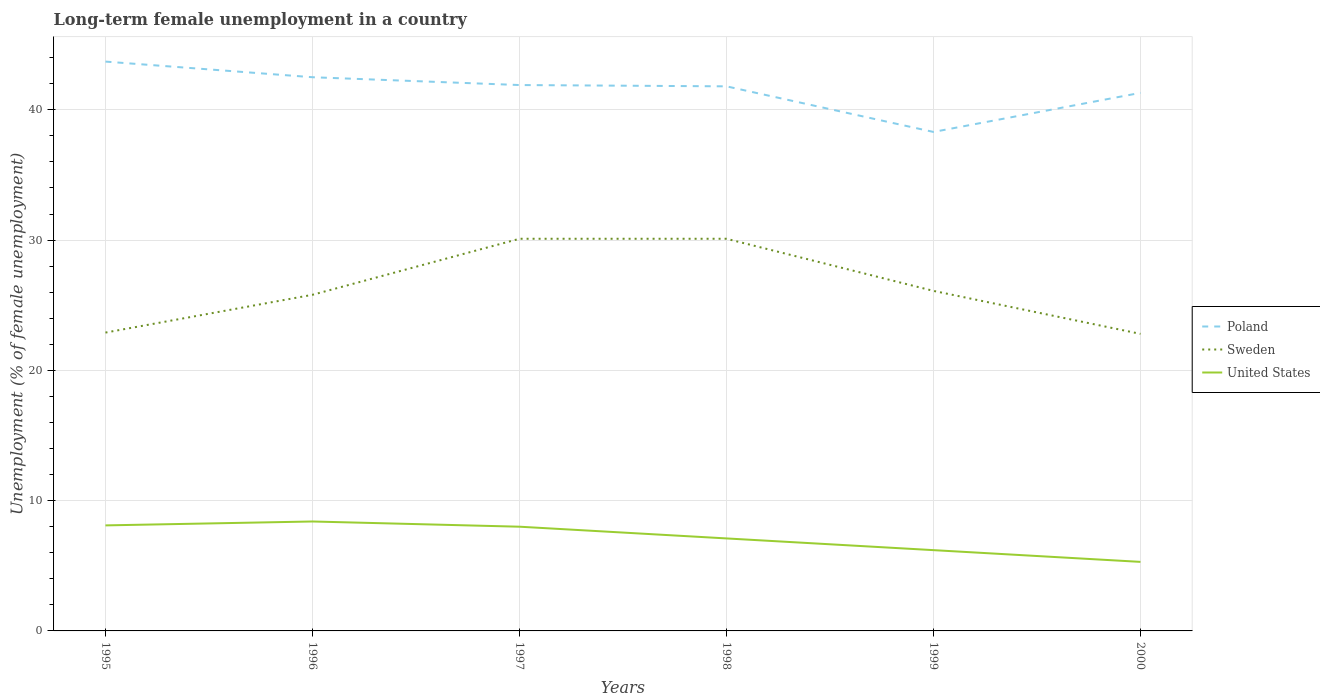How many different coloured lines are there?
Ensure brevity in your answer.  3. Across all years, what is the maximum percentage of long-term unemployed female population in Poland?
Your response must be concise. 38.3. What is the total percentage of long-term unemployed female population in Poland in the graph?
Offer a very short reply. 1.9. What is the difference between the highest and the second highest percentage of long-term unemployed female population in United States?
Keep it short and to the point. 3.1. What is the difference between the highest and the lowest percentage of long-term unemployed female population in United States?
Provide a short and direct response. 3. How many years are there in the graph?
Offer a very short reply. 6. What is the difference between two consecutive major ticks on the Y-axis?
Provide a succinct answer. 10. Are the values on the major ticks of Y-axis written in scientific E-notation?
Provide a short and direct response. No. Does the graph contain any zero values?
Your answer should be compact. No. How are the legend labels stacked?
Ensure brevity in your answer.  Vertical. What is the title of the graph?
Provide a succinct answer. Long-term female unemployment in a country. What is the label or title of the X-axis?
Offer a very short reply. Years. What is the label or title of the Y-axis?
Your answer should be very brief. Unemployment (% of female unemployment). What is the Unemployment (% of female unemployment) in Poland in 1995?
Your answer should be very brief. 43.7. What is the Unemployment (% of female unemployment) in Sweden in 1995?
Offer a terse response. 22.9. What is the Unemployment (% of female unemployment) of United States in 1995?
Keep it short and to the point. 8.1. What is the Unemployment (% of female unemployment) of Poland in 1996?
Offer a very short reply. 42.5. What is the Unemployment (% of female unemployment) in Sweden in 1996?
Give a very brief answer. 25.8. What is the Unemployment (% of female unemployment) of United States in 1996?
Provide a succinct answer. 8.4. What is the Unemployment (% of female unemployment) in Poland in 1997?
Your response must be concise. 41.9. What is the Unemployment (% of female unemployment) of Sweden in 1997?
Your answer should be compact. 30.1. What is the Unemployment (% of female unemployment) in Poland in 1998?
Provide a succinct answer. 41.8. What is the Unemployment (% of female unemployment) in Sweden in 1998?
Offer a very short reply. 30.1. What is the Unemployment (% of female unemployment) in United States in 1998?
Keep it short and to the point. 7.1. What is the Unemployment (% of female unemployment) of Poland in 1999?
Offer a very short reply. 38.3. What is the Unemployment (% of female unemployment) in Sweden in 1999?
Keep it short and to the point. 26.1. What is the Unemployment (% of female unemployment) of United States in 1999?
Your answer should be compact. 6.2. What is the Unemployment (% of female unemployment) in Poland in 2000?
Ensure brevity in your answer.  41.3. What is the Unemployment (% of female unemployment) in Sweden in 2000?
Your answer should be very brief. 22.8. What is the Unemployment (% of female unemployment) in United States in 2000?
Your response must be concise. 5.3. Across all years, what is the maximum Unemployment (% of female unemployment) in Poland?
Your response must be concise. 43.7. Across all years, what is the maximum Unemployment (% of female unemployment) of Sweden?
Ensure brevity in your answer.  30.1. Across all years, what is the maximum Unemployment (% of female unemployment) in United States?
Provide a short and direct response. 8.4. Across all years, what is the minimum Unemployment (% of female unemployment) in Poland?
Provide a succinct answer. 38.3. Across all years, what is the minimum Unemployment (% of female unemployment) of Sweden?
Offer a very short reply. 22.8. Across all years, what is the minimum Unemployment (% of female unemployment) in United States?
Make the answer very short. 5.3. What is the total Unemployment (% of female unemployment) of Poland in the graph?
Offer a very short reply. 249.5. What is the total Unemployment (% of female unemployment) in Sweden in the graph?
Your response must be concise. 157.8. What is the total Unemployment (% of female unemployment) of United States in the graph?
Provide a succinct answer. 43.1. What is the difference between the Unemployment (% of female unemployment) of Poland in 1995 and that in 1996?
Offer a terse response. 1.2. What is the difference between the Unemployment (% of female unemployment) in Sweden in 1995 and that in 1997?
Keep it short and to the point. -7.2. What is the difference between the Unemployment (% of female unemployment) of Poland in 1995 and that in 1998?
Offer a terse response. 1.9. What is the difference between the Unemployment (% of female unemployment) of United States in 1995 and that in 1998?
Your answer should be compact. 1. What is the difference between the Unemployment (% of female unemployment) of Poland in 1995 and that in 2000?
Provide a succinct answer. 2.4. What is the difference between the Unemployment (% of female unemployment) in Sweden in 1995 and that in 2000?
Offer a very short reply. 0.1. What is the difference between the Unemployment (% of female unemployment) in Poland in 1996 and that in 1997?
Offer a terse response. 0.6. What is the difference between the Unemployment (% of female unemployment) of United States in 1996 and that in 1997?
Ensure brevity in your answer.  0.4. What is the difference between the Unemployment (% of female unemployment) in Sweden in 1996 and that in 1998?
Give a very brief answer. -4.3. What is the difference between the Unemployment (% of female unemployment) in Sweden in 1996 and that in 2000?
Offer a terse response. 3. What is the difference between the Unemployment (% of female unemployment) of United States in 1996 and that in 2000?
Give a very brief answer. 3.1. What is the difference between the Unemployment (% of female unemployment) of Poland in 1997 and that in 1998?
Your answer should be compact. 0.1. What is the difference between the Unemployment (% of female unemployment) of Poland in 1997 and that in 1999?
Your answer should be compact. 3.6. What is the difference between the Unemployment (% of female unemployment) in Sweden in 1997 and that in 1999?
Provide a short and direct response. 4. What is the difference between the Unemployment (% of female unemployment) of United States in 1997 and that in 1999?
Give a very brief answer. 1.8. What is the difference between the Unemployment (% of female unemployment) in Poland in 1997 and that in 2000?
Offer a very short reply. 0.6. What is the difference between the Unemployment (% of female unemployment) in Sweden in 1997 and that in 2000?
Provide a succinct answer. 7.3. What is the difference between the Unemployment (% of female unemployment) of Sweden in 1998 and that in 1999?
Your answer should be very brief. 4. What is the difference between the Unemployment (% of female unemployment) in Poland in 1998 and that in 2000?
Your response must be concise. 0.5. What is the difference between the Unemployment (% of female unemployment) in Sweden in 1998 and that in 2000?
Your answer should be very brief. 7.3. What is the difference between the Unemployment (% of female unemployment) in United States in 1998 and that in 2000?
Your answer should be compact. 1.8. What is the difference between the Unemployment (% of female unemployment) of Sweden in 1999 and that in 2000?
Provide a succinct answer. 3.3. What is the difference between the Unemployment (% of female unemployment) of United States in 1999 and that in 2000?
Provide a succinct answer. 0.9. What is the difference between the Unemployment (% of female unemployment) in Poland in 1995 and the Unemployment (% of female unemployment) in Sweden in 1996?
Your answer should be very brief. 17.9. What is the difference between the Unemployment (% of female unemployment) in Poland in 1995 and the Unemployment (% of female unemployment) in United States in 1996?
Your answer should be very brief. 35.3. What is the difference between the Unemployment (% of female unemployment) in Sweden in 1995 and the Unemployment (% of female unemployment) in United States in 1996?
Your answer should be compact. 14.5. What is the difference between the Unemployment (% of female unemployment) of Poland in 1995 and the Unemployment (% of female unemployment) of United States in 1997?
Provide a succinct answer. 35.7. What is the difference between the Unemployment (% of female unemployment) of Poland in 1995 and the Unemployment (% of female unemployment) of United States in 1998?
Provide a succinct answer. 36.6. What is the difference between the Unemployment (% of female unemployment) in Poland in 1995 and the Unemployment (% of female unemployment) in Sweden in 1999?
Your response must be concise. 17.6. What is the difference between the Unemployment (% of female unemployment) of Poland in 1995 and the Unemployment (% of female unemployment) of United States in 1999?
Your answer should be very brief. 37.5. What is the difference between the Unemployment (% of female unemployment) in Poland in 1995 and the Unemployment (% of female unemployment) in Sweden in 2000?
Give a very brief answer. 20.9. What is the difference between the Unemployment (% of female unemployment) of Poland in 1995 and the Unemployment (% of female unemployment) of United States in 2000?
Make the answer very short. 38.4. What is the difference between the Unemployment (% of female unemployment) of Sweden in 1995 and the Unemployment (% of female unemployment) of United States in 2000?
Provide a succinct answer. 17.6. What is the difference between the Unemployment (% of female unemployment) of Poland in 1996 and the Unemployment (% of female unemployment) of United States in 1997?
Offer a terse response. 34.5. What is the difference between the Unemployment (% of female unemployment) of Poland in 1996 and the Unemployment (% of female unemployment) of United States in 1998?
Provide a short and direct response. 35.4. What is the difference between the Unemployment (% of female unemployment) in Poland in 1996 and the Unemployment (% of female unemployment) in United States in 1999?
Ensure brevity in your answer.  36.3. What is the difference between the Unemployment (% of female unemployment) in Sweden in 1996 and the Unemployment (% of female unemployment) in United States in 1999?
Your answer should be compact. 19.6. What is the difference between the Unemployment (% of female unemployment) of Poland in 1996 and the Unemployment (% of female unemployment) of United States in 2000?
Your answer should be compact. 37.2. What is the difference between the Unemployment (% of female unemployment) in Sweden in 1996 and the Unemployment (% of female unemployment) in United States in 2000?
Make the answer very short. 20.5. What is the difference between the Unemployment (% of female unemployment) of Poland in 1997 and the Unemployment (% of female unemployment) of Sweden in 1998?
Make the answer very short. 11.8. What is the difference between the Unemployment (% of female unemployment) in Poland in 1997 and the Unemployment (% of female unemployment) in United States in 1998?
Your response must be concise. 34.8. What is the difference between the Unemployment (% of female unemployment) in Sweden in 1997 and the Unemployment (% of female unemployment) in United States in 1998?
Provide a succinct answer. 23. What is the difference between the Unemployment (% of female unemployment) of Poland in 1997 and the Unemployment (% of female unemployment) of Sweden in 1999?
Offer a very short reply. 15.8. What is the difference between the Unemployment (% of female unemployment) of Poland in 1997 and the Unemployment (% of female unemployment) of United States in 1999?
Offer a very short reply. 35.7. What is the difference between the Unemployment (% of female unemployment) in Sweden in 1997 and the Unemployment (% of female unemployment) in United States in 1999?
Your answer should be very brief. 23.9. What is the difference between the Unemployment (% of female unemployment) in Poland in 1997 and the Unemployment (% of female unemployment) in United States in 2000?
Offer a terse response. 36.6. What is the difference between the Unemployment (% of female unemployment) of Sweden in 1997 and the Unemployment (% of female unemployment) of United States in 2000?
Make the answer very short. 24.8. What is the difference between the Unemployment (% of female unemployment) in Poland in 1998 and the Unemployment (% of female unemployment) in Sweden in 1999?
Offer a very short reply. 15.7. What is the difference between the Unemployment (% of female unemployment) of Poland in 1998 and the Unemployment (% of female unemployment) of United States in 1999?
Give a very brief answer. 35.6. What is the difference between the Unemployment (% of female unemployment) of Sweden in 1998 and the Unemployment (% of female unemployment) of United States in 1999?
Your response must be concise. 23.9. What is the difference between the Unemployment (% of female unemployment) of Poland in 1998 and the Unemployment (% of female unemployment) of Sweden in 2000?
Give a very brief answer. 19. What is the difference between the Unemployment (% of female unemployment) of Poland in 1998 and the Unemployment (% of female unemployment) of United States in 2000?
Offer a terse response. 36.5. What is the difference between the Unemployment (% of female unemployment) of Sweden in 1998 and the Unemployment (% of female unemployment) of United States in 2000?
Give a very brief answer. 24.8. What is the difference between the Unemployment (% of female unemployment) of Sweden in 1999 and the Unemployment (% of female unemployment) of United States in 2000?
Give a very brief answer. 20.8. What is the average Unemployment (% of female unemployment) of Poland per year?
Keep it short and to the point. 41.58. What is the average Unemployment (% of female unemployment) in Sweden per year?
Provide a short and direct response. 26.3. What is the average Unemployment (% of female unemployment) of United States per year?
Offer a terse response. 7.18. In the year 1995, what is the difference between the Unemployment (% of female unemployment) of Poland and Unemployment (% of female unemployment) of Sweden?
Your answer should be very brief. 20.8. In the year 1995, what is the difference between the Unemployment (% of female unemployment) of Poland and Unemployment (% of female unemployment) of United States?
Your answer should be very brief. 35.6. In the year 1995, what is the difference between the Unemployment (% of female unemployment) in Sweden and Unemployment (% of female unemployment) in United States?
Make the answer very short. 14.8. In the year 1996, what is the difference between the Unemployment (% of female unemployment) of Poland and Unemployment (% of female unemployment) of Sweden?
Offer a terse response. 16.7. In the year 1996, what is the difference between the Unemployment (% of female unemployment) in Poland and Unemployment (% of female unemployment) in United States?
Make the answer very short. 34.1. In the year 1996, what is the difference between the Unemployment (% of female unemployment) of Sweden and Unemployment (% of female unemployment) of United States?
Your answer should be compact. 17.4. In the year 1997, what is the difference between the Unemployment (% of female unemployment) in Poland and Unemployment (% of female unemployment) in Sweden?
Your answer should be very brief. 11.8. In the year 1997, what is the difference between the Unemployment (% of female unemployment) of Poland and Unemployment (% of female unemployment) of United States?
Make the answer very short. 33.9. In the year 1997, what is the difference between the Unemployment (% of female unemployment) of Sweden and Unemployment (% of female unemployment) of United States?
Provide a short and direct response. 22.1. In the year 1998, what is the difference between the Unemployment (% of female unemployment) in Poland and Unemployment (% of female unemployment) in Sweden?
Your response must be concise. 11.7. In the year 1998, what is the difference between the Unemployment (% of female unemployment) in Poland and Unemployment (% of female unemployment) in United States?
Provide a short and direct response. 34.7. In the year 1998, what is the difference between the Unemployment (% of female unemployment) of Sweden and Unemployment (% of female unemployment) of United States?
Make the answer very short. 23. In the year 1999, what is the difference between the Unemployment (% of female unemployment) of Poland and Unemployment (% of female unemployment) of United States?
Keep it short and to the point. 32.1. In the year 1999, what is the difference between the Unemployment (% of female unemployment) in Sweden and Unemployment (% of female unemployment) in United States?
Your response must be concise. 19.9. In the year 2000, what is the difference between the Unemployment (% of female unemployment) in Poland and Unemployment (% of female unemployment) in Sweden?
Keep it short and to the point. 18.5. In the year 2000, what is the difference between the Unemployment (% of female unemployment) in Poland and Unemployment (% of female unemployment) in United States?
Make the answer very short. 36. What is the ratio of the Unemployment (% of female unemployment) of Poland in 1995 to that in 1996?
Make the answer very short. 1.03. What is the ratio of the Unemployment (% of female unemployment) in Sweden in 1995 to that in 1996?
Ensure brevity in your answer.  0.89. What is the ratio of the Unemployment (% of female unemployment) in United States in 1995 to that in 1996?
Provide a short and direct response. 0.96. What is the ratio of the Unemployment (% of female unemployment) in Poland in 1995 to that in 1997?
Make the answer very short. 1.04. What is the ratio of the Unemployment (% of female unemployment) in Sweden in 1995 to that in 1997?
Give a very brief answer. 0.76. What is the ratio of the Unemployment (% of female unemployment) in United States in 1995 to that in 1997?
Offer a very short reply. 1.01. What is the ratio of the Unemployment (% of female unemployment) of Poland in 1995 to that in 1998?
Your answer should be very brief. 1.05. What is the ratio of the Unemployment (% of female unemployment) of Sweden in 1995 to that in 1998?
Make the answer very short. 0.76. What is the ratio of the Unemployment (% of female unemployment) in United States in 1995 to that in 1998?
Your answer should be compact. 1.14. What is the ratio of the Unemployment (% of female unemployment) in Poland in 1995 to that in 1999?
Offer a terse response. 1.14. What is the ratio of the Unemployment (% of female unemployment) of Sweden in 1995 to that in 1999?
Provide a succinct answer. 0.88. What is the ratio of the Unemployment (% of female unemployment) in United States in 1995 to that in 1999?
Your answer should be compact. 1.31. What is the ratio of the Unemployment (% of female unemployment) of Poland in 1995 to that in 2000?
Keep it short and to the point. 1.06. What is the ratio of the Unemployment (% of female unemployment) of United States in 1995 to that in 2000?
Offer a very short reply. 1.53. What is the ratio of the Unemployment (% of female unemployment) in Poland in 1996 to that in 1997?
Make the answer very short. 1.01. What is the ratio of the Unemployment (% of female unemployment) of Poland in 1996 to that in 1998?
Your answer should be compact. 1.02. What is the ratio of the Unemployment (% of female unemployment) of United States in 1996 to that in 1998?
Provide a short and direct response. 1.18. What is the ratio of the Unemployment (% of female unemployment) in Poland in 1996 to that in 1999?
Your answer should be compact. 1.11. What is the ratio of the Unemployment (% of female unemployment) of United States in 1996 to that in 1999?
Offer a terse response. 1.35. What is the ratio of the Unemployment (% of female unemployment) in Poland in 1996 to that in 2000?
Give a very brief answer. 1.03. What is the ratio of the Unemployment (% of female unemployment) of Sweden in 1996 to that in 2000?
Provide a succinct answer. 1.13. What is the ratio of the Unemployment (% of female unemployment) in United States in 1996 to that in 2000?
Keep it short and to the point. 1.58. What is the ratio of the Unemployment (% of female unemployment) of United States in 1997 to that in 1998?
Ensure brevity in your answer.  1.13. What is the ratio of the Unemployment (% of female unemployment) of Poland in 1997 to that in 1999?
Provide a short and direct response. 1.09. What is the ratio of the Unemployment (% of female unemployment) in Sweden in 1997 to that in 1999?
Provide a short and direct response. 1.15. What is the ratio of the Unemployment (% of female unemployment) in United States in 1997 to that in 1999?
Your answer should be compact. 1.29. What is the ratio of the Unemployment (% of female unemployment) in Poland in 1997 to that in 2000?
Make the answer very short. 1.01. What is the ratio of the Unemployment (% of female unemployment) in Sweden in 1997 to that in 2000?
Your response must be concise. 1.32. What is the ratio of the Unemployment (% of female unemployment) of United States in 1997 to that in 2000?
Offer a very short reply. 1.51. What is the ratio of the Unemployment (% of female unemployment) in Poland in 1998 to that in 1999?
Your answer should be very brief. 1.09. What is the ratio of the Unemployment (% of female unemployment) in Sweden in 1998 to that in 1999?
Keep it short and to the point. 1.15. What is the ratio of the Unemployment (% of female unemployment) of United States in 1998 to that in 1999?
Provide a succinct answer. 1.15. What is the ratio of the Unemployment (% of female unemployment) in Poland in 1998 to that in 2000?
Keep it short and to the point. 1.01. What is the ratio of the Unemployment (% of female unemployment) in Sweden in 1998 to that in 2000?
Make the answer very short. 1.32. What is the ratio of the Unemployment (% of female unemployment) of United States in 1998 to that in 2000?
Ensure brevity in your answer.  1.34. What is the ratio of the Unemployment (% of female unemployment) in Poland in 1999 to that in 2000?
Ensure brevity in your answer.  0.93. What is the ratio of the Unemployment (% of female unemployment) in Sweden in 1999 to that in 2000?
Offer a terse response. 1.14. What is the ratio of the Unemployment (% of female unemployment) in United States in 1999 to that in 2000?
Give a very brief answer. 1.17. What is the difference between the highest and the second highest Unemployment (% of female unemployment) in Poland?
Keep it short and to the point. 1.2. What is the difference between the highest and the second highest Unemployment (% of female unemployment) in United States?
Offer a very short reply. 0.3. What is the difference between the highest and the lowest Unemployment (% of female unemployment) in Poland?
Your answer should be very brief. 5.4. What is the difference between the highest and the lowest Unemployment (% of female unemployment) in Sweden?
Offer a terse response. 7.3. What is the difference between the highest and the lowest Unemployment (% of female unemployment) of United States?
Provide a succinct answer. 3.1. 